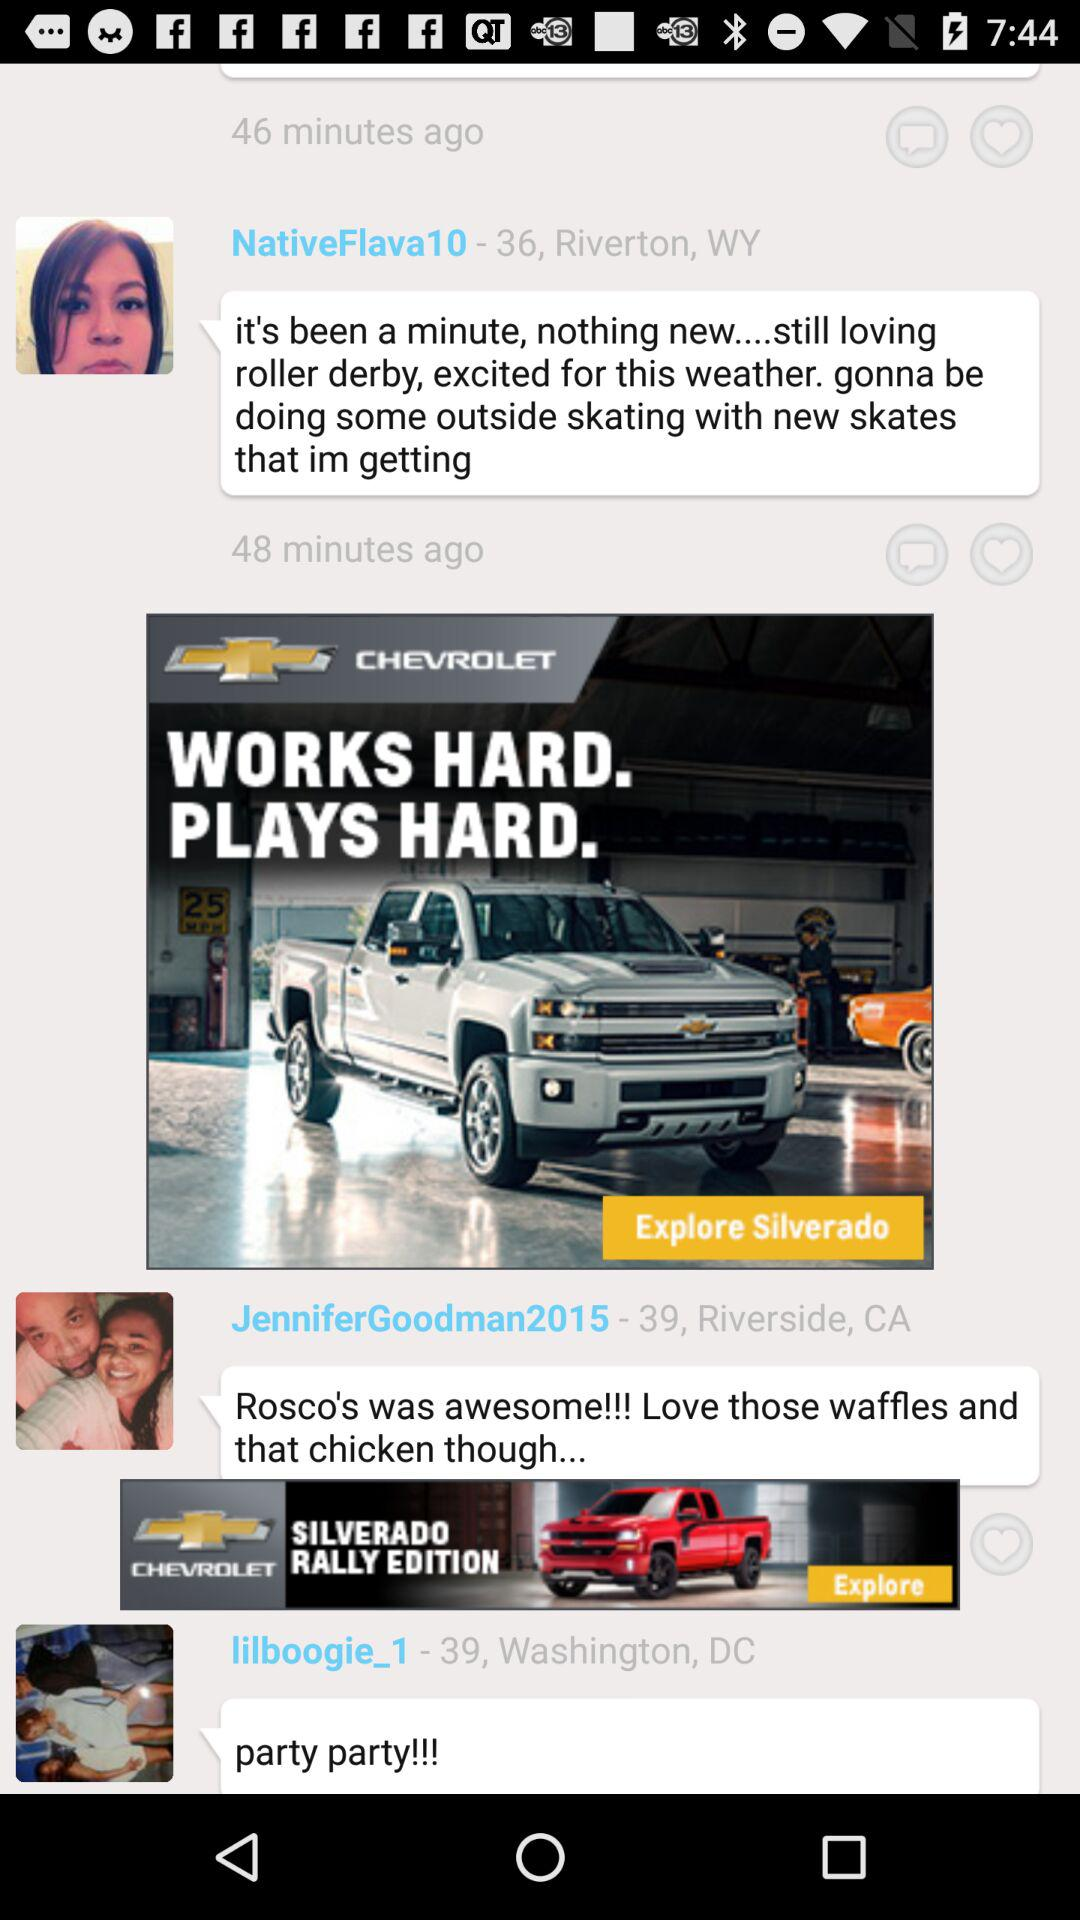On what day were the messages sent?
When the provided information is insufficient, respond with <no answer>. <no answer> 